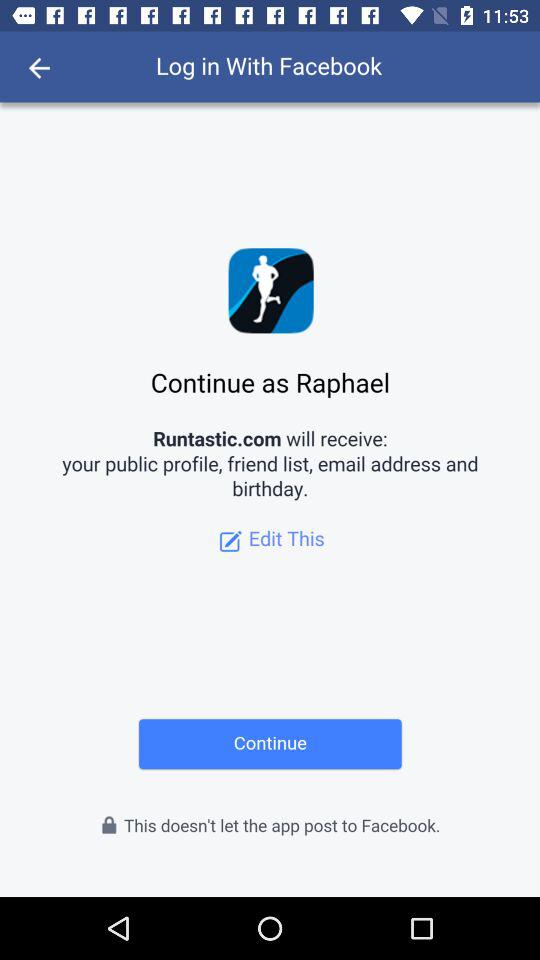What website will receive the public profile, friend list, and email address? The website is "Runtastic.com". 